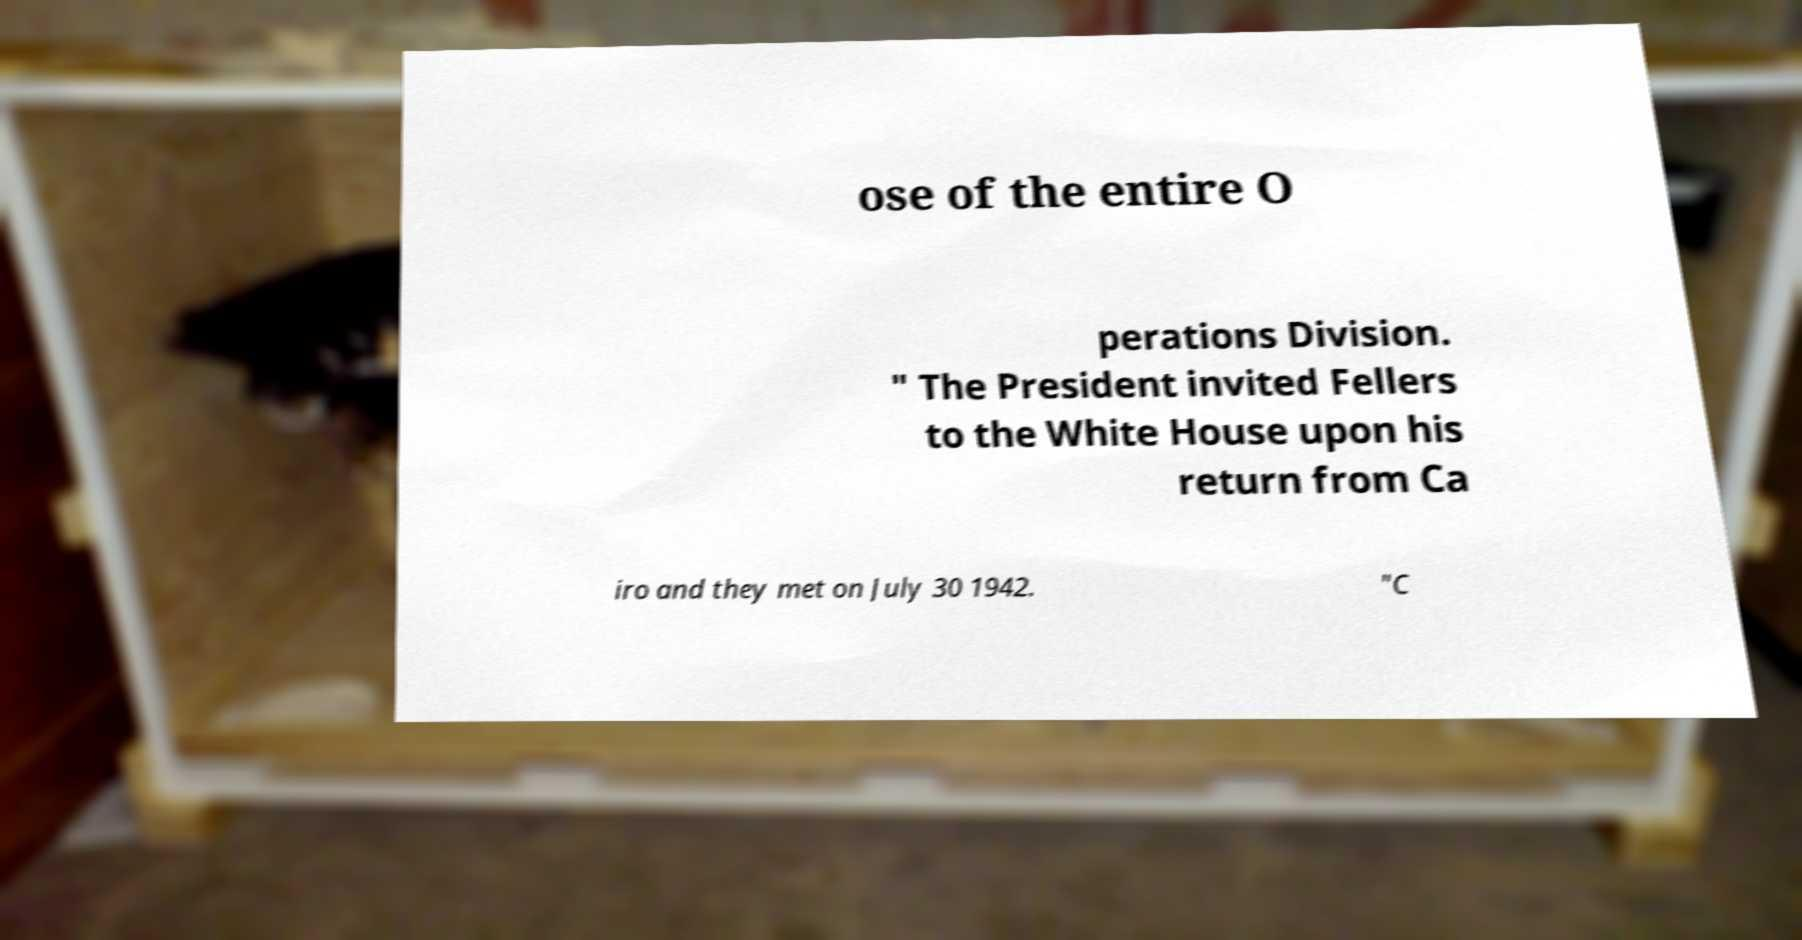Could you extract and type out the text from this image? ose of the entire O perations Division. " The President invited Fellers to the White House upon his return from Ca iro and they met on July 30 1942. "C 